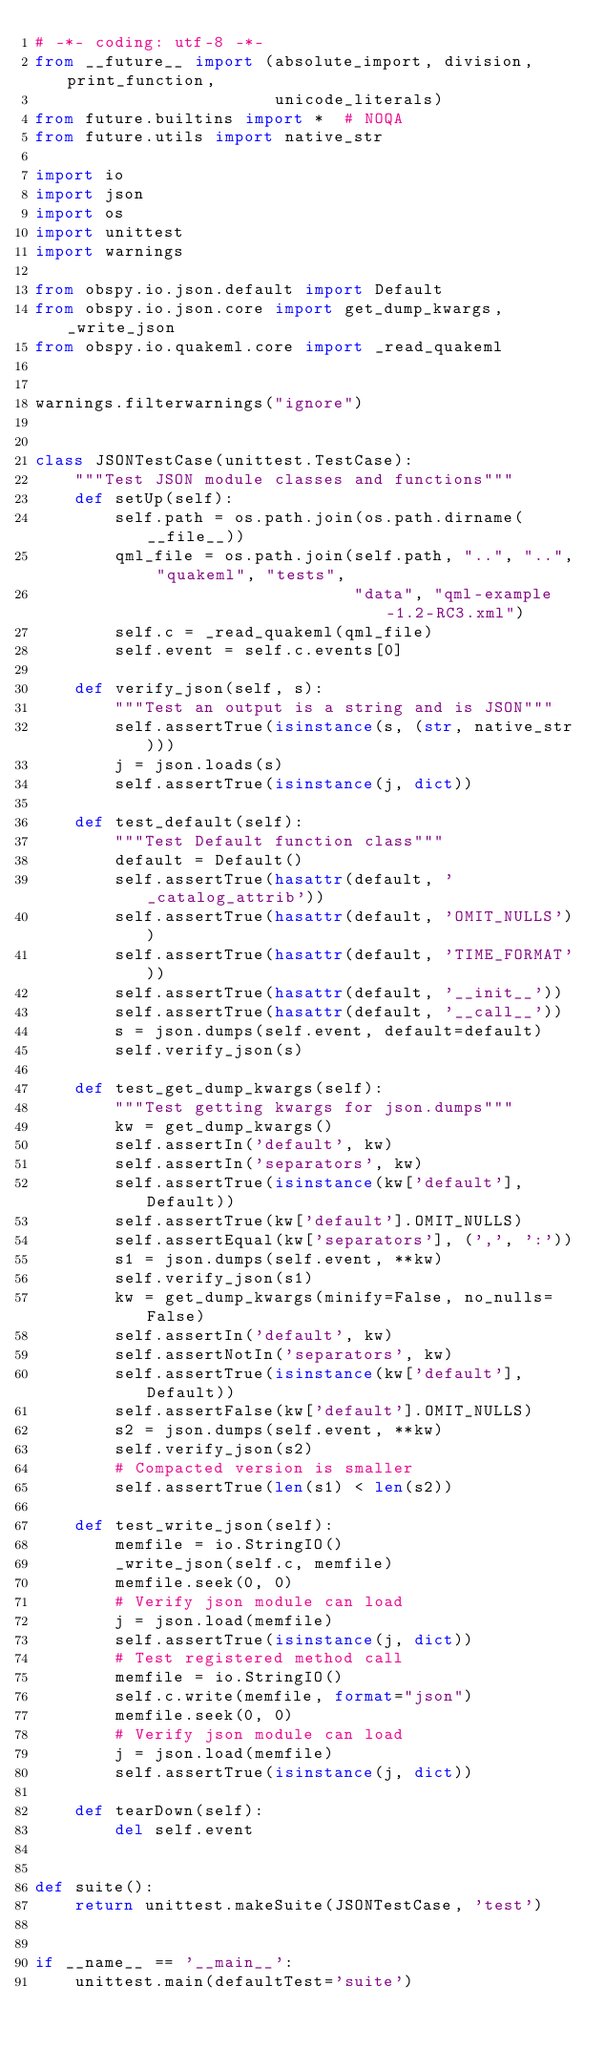Convert code to text. <code><loc_0><loc_0><loc_500><loc_500><_Python_># -*- coding: utf-8 -*-
from __future__ import (absolute_import, division, print_function,
                        unicode_literals)
from future.builtins import *  # NOQA
from future.utils import native_str

import io
import json
import os
import unittest
import warnings

from obspy.io.json.default import Default
from obspy.io.json.core import get_dump_kwargs, _write_json
from obspy.io.quakeml.core import _read_quakeml


warnings.filterwarnings("ignore")


class JSONTestCase(unittest.TestCase):
    """Test JSON module classes and functions"""
    def setUp(self):
        self.path = os.path.join(os.path.dirname(__file__))
        qml_file = os.path.join(self.path, "..", "..", "quakeml", "tests",
                                "data", "qml-example-1.2-RC3.xml")
        self.c = _read_quakeml(qml_file)
        self.event = self.c.events[0]

    def verify_json(self, s):
        """Test an output is a string and is JSON"""
        self.assertTrue(isinstance(s, (str, native_str)))
        j = json.loads(s)
        self.assertTrue(isinstance(j, dict))

    def test_default(self):
        """Test Default function class"""
        default = Default()
        self.assertTrue(hasattr(default, '_catalog_attrib'))
        self.assertTrue(hasattr(default, 'OMIT_NULLS'))
        self.assertTrue(hasattr(default, 'TIME_FORMAT'))
        self.assertTrue(hasattr(default, '__init__'))
        self.assertTrue(hasattr(default, '__call__'))
        s = json.dumps(self.event, default=default)
        self.verify_json(s)

    def test_get_dump_kwargs(self):
        """Test getting kwargs for json.dumps"""
        kw = get_dump_kwargs()
        self.assertIn('default', kw)
        self.assertIn('separators', kw)
        self.assertTrue(isinstance(kw['default'], Default))
        self.assertTrue(kw['default'].OMIT_NULLS)
        self.assertEqual(kw['separators'], (',', ':'))
        s1 = json.dumps(self.event, **kw)
        self.verify_json(s1)
        kw = get_dump_kwargs(minify=False, no_nulls=False)
        self.assertIn('default', kw)
        self.assertNotIn('separators', kw)
        self.assertTrue(isinstance(kw['default'], Default))
        self.assertFalse(kw['default'].OMIT_NULLS)
        s2 = json.dumps(self.event, **kw)
        self.verify_json(s2)
        # Compacted version is smaller
        self.assertTrue(len(s1) < len(s2))

    def test_write_json(self):
        memfile = io.StringIO()
        _write_json(self.c, memfile)
        memfile.seek(0, 0)
        # Verify json module can load
        j = json.load(memfile)
        self.assertTrue(isinstance(j, dict))
        # Test registered method call
        memfile = io.StringIO()
        self.c.write(memfile, format="json")
        memfile.seek(0, 0)
        # Verify json module can load
        j = json.load(memfile)
        self.assertTrue(isinstance(j, dict))

    def tearDown(self):
        del self.event


def suite():
    return unittest.makeSuite(JSONTestCase, 'test')


if __name__ == '__main__':
    unittest.main(defaultTest='suite')
</code> 